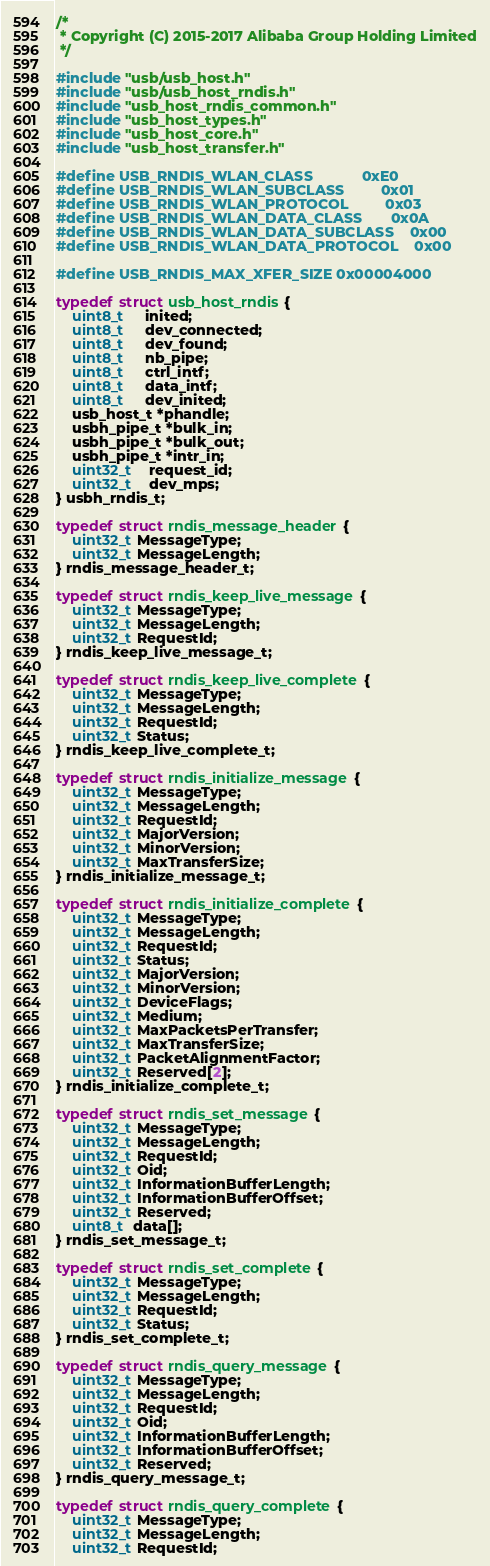<code> <loc_0><loc_0><loc_500><loc_500><_C_>/*
 * Copyright (C) 2015-2017 Alibaba Group Holding Limited
 */

#include "usb/usb_host.h"
#include "usb/usb_host_rndis.h"
#include "usb_host_rndis_common.h"
#include "usb_host_types.h"
#include "usb_host_core.h"
#include "usb_host_transfer.h"

#define USB_RNDIS_WLAN_CLASS            0xE0
#define USB_RNDIS_WLAN_SUBCLASS         0x01
#define USB_RNDIS_WLAN_PROTOCOL         0x03
#define USB_RNDIS_WLAN_DATA_CLASS       0x0A
#define USB_RNDIS_WLAN_DATA_SUBCLASS    0x00
#define USB_RNDIS_WLAN_DATA_PROTOCOL    0x00

#define USB_RNDIS_MAX_XFER_SIZE 0x00004000

typedef struct usb_host_rndis {
    uint8_t     inited;
    uint8_t     dev_connected;
    uint8_t     dev_found;
    uint8_t     nb_pipe;
    uint8_t     ctrl_intf;
    uint8_t     data_intf;
    uint8_t     dev_inited;
    usb_host_t *phandle;
    usbh_pipe_t *bulk_in;
    usbh_pipe_t *bulk_out;
    usbh_pipe_t *intr_in;
    uint32_t    request_id;
    uint32_t    dev_mps;
} usbh_rndis_t;

typedef struct rndis_message_header {
    uint32_t MessageType;
    uint32_t MessageLength;   
} rndis_message_header_t;

typedef struct rndis_keep_live_message {
    uint32_t MessageType;
    uint32_t MessageLength;
    uint32_t RequestId;
} rndis_keep_live_message_t;

typedef struct rndis_keep_live_complete {
    uint32_t MessageType;
    uint32_t MessageLength;
    uint32_t RequestId;
    uint32_t Status;
} rndis_keep_live_complete_t;

typedef struct rndis_initialize_message {
    uint32_t MessageType;
    uint32_t MessageLength;
    uint32_t RequestId;
    uint32_t MajorVersion;
    uint32_t MinorVersion;
    uint32_t MaxTransferSize;
} rndis_initialize_message_t;

typedef struct rndis_initialize_complete {
    uint32_t MessageType;
    uint32_t MessageLength;
    uint32_t RequestId;
    uint32_t Status;
    uint32_t MajorVersion;
    uint32_t MinorVersion;
    uint32_t DeviceFlags;
    uint32_t Medium;
    uint32_t MaxPacketsPerTransfer;
    uint32_t MaxTransferSize;
    uint32_t PacketAlignmentFactor;
    uint32_t Reserved[2];
} rndis_initialize_complete_t;

typedef struct rndis_set_message {
    uint32_t MessageType;
    uint32_t MessageLength;
    uint32_t RequestId;
    uint32_t Oid;
    uint32_t InformationBufferLength;
    uint32_t InformationBufferOffset;
    uint32_t Reserved;
    uint8_t  data[];
} rndis_set_message_t;

typedef struct rndis_set_complete {
    uint32_t MessageType;
    uint32_t MessageLength;
    uint32_t RequestId;
    uint32_t Status;
} rndis_set_complete_t;

typedef struct rndis_query_message {
    uint32_t MessageType;
    uint32_t MessageLength;
    uint32_t RequestId;
    uint32_t Oid;
    uint32_t InformationBufferLength;
    uint32_t InformationBufferOffset;
    uint32_t Reserved;
} rndis_query_message_t;

typedef struct rndis_query_complete {
    uint32_t MessageType;
    uint32_t MessageLength;
    uint32_t RequestId;</code> 